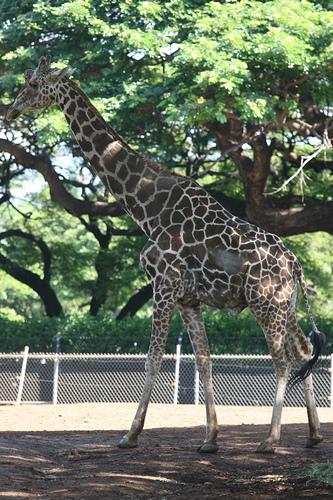What animal is in the photo?
Give a very brief answer. Giraffe. Do Americans usually render and consume many of these creatures?
Short answer required. No. Is the giraffe grazing?
Keep it brief. No. 